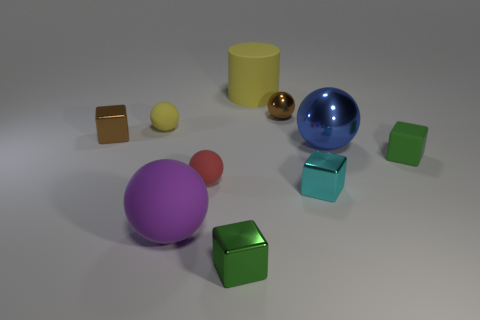There is a red ball that is the same size as the brown shiny cube; what material is it?
Offer a terse response. Rubber. There is a tiny red object that is the same shape as the purple object; what is its material?
Your response must be concise. Rubber. What number of things are either small green matte blocks or tiny green blocks?
Ensure brevity in your answer.  2. What shape is the small metal thing that is left of the small green cube that is to the left of the rubber cylinder?
Keep it short and to the point. Cube. What number of other things are there of the same material as the large blue object
Give a very brief answer. 4. Is the big blue ball made of the same material as the tiny object to the right of the large blue sphere?
Your answer should be very brief. No. How many objects are large spheres that are in front of the large blue thing or rubber things to the left of the rubber cylinder?
Provide a succinct answer. 3. What number of other objects are the same color as the big shiny ball?
Keep it short and to the point. 0. Is the number of tiny matte balls to the right of the big purple matte sphere greater than the number of yellow balls in front of the red rubber thing?
Ensure brevity in your answer.  Yes. How many cylinders are brown metallic objects or tiny gray things?
Provide a short and direct response. 0. 